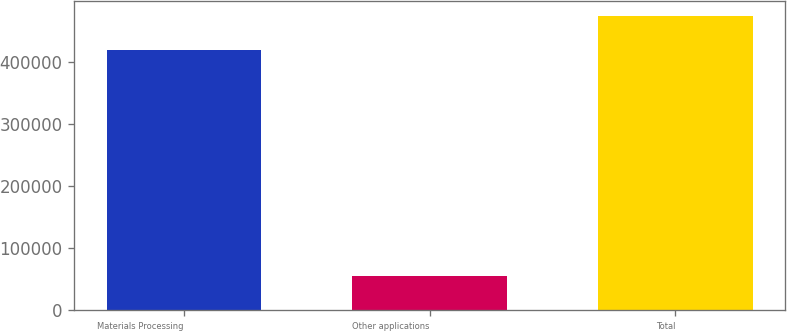<chart> <loc_0><loc_0><loc_500><loc_500><bar_chart><fcel>Materials Processing<fcel>Other applications<fcel>Total<nl><fcel>419443<fcel>55039<fcel>474482<nl></chart> 